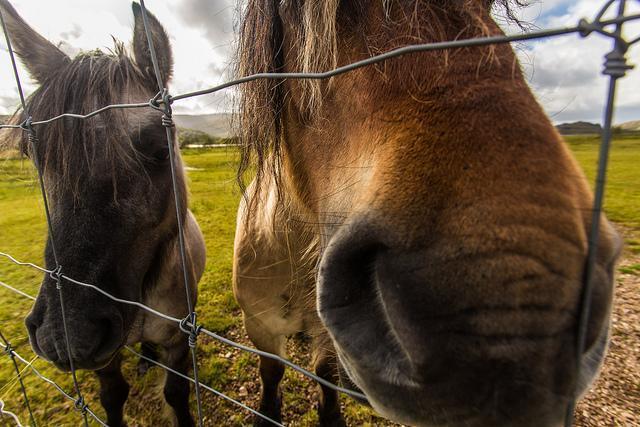How many horses are there?
Give a very brief answer. 2. 